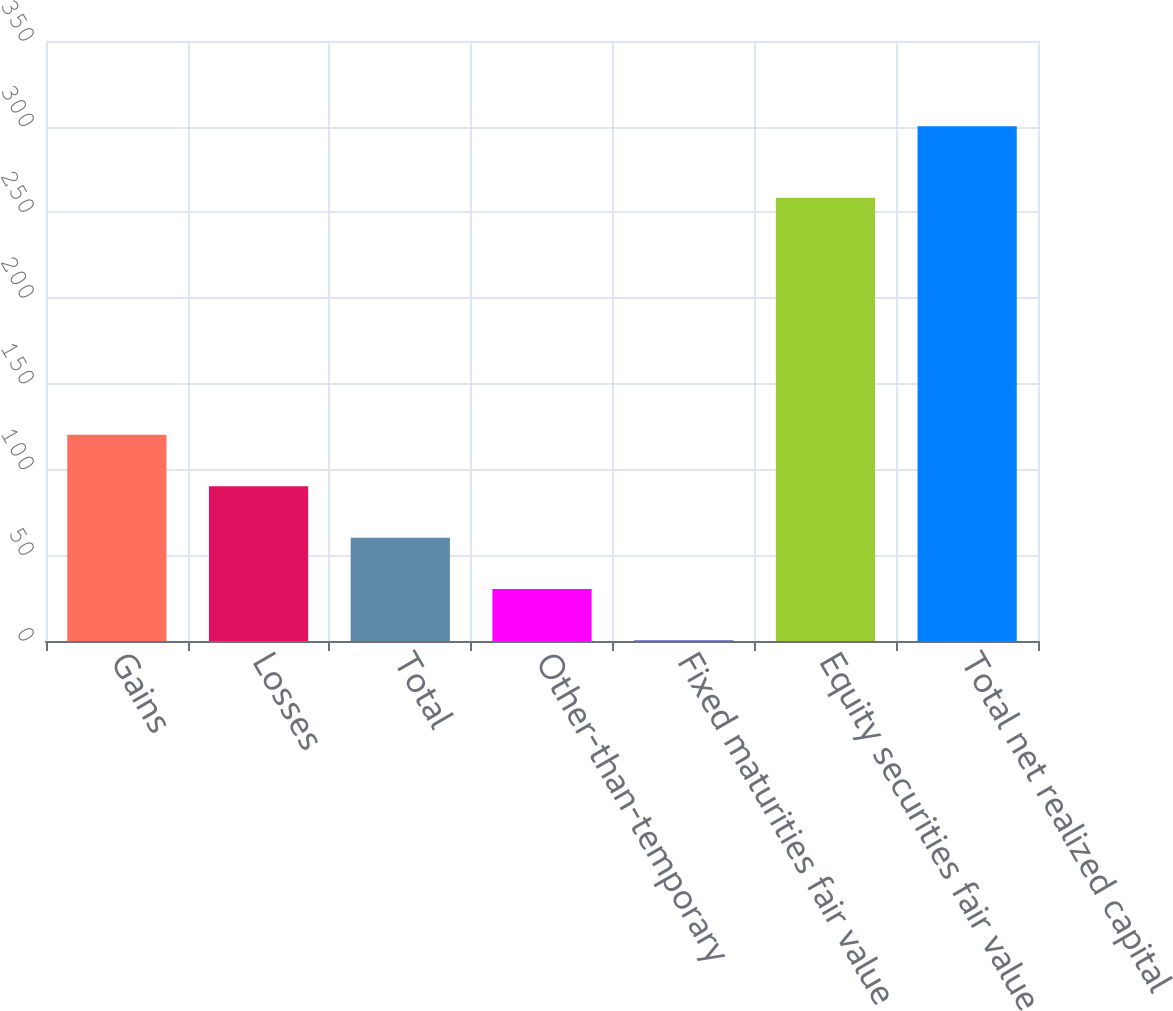Convert chart to OTSL. <chart><loc_0><loc_0><loc_500><loc_500><bar_chart><fcel>Gains<fcel>Losses<fcel>Total<fcel>Other-than-temporary<fcel>Fixed maturities fair value<fcel>Equity securities fair value<fcel>Total net realized capital<nl><fcel>120.26<fcel>90.27<fcel>60.28<fcel>30.29<fcel>0.3<fcel>258.6<fcel>300.2<nl></chart> 